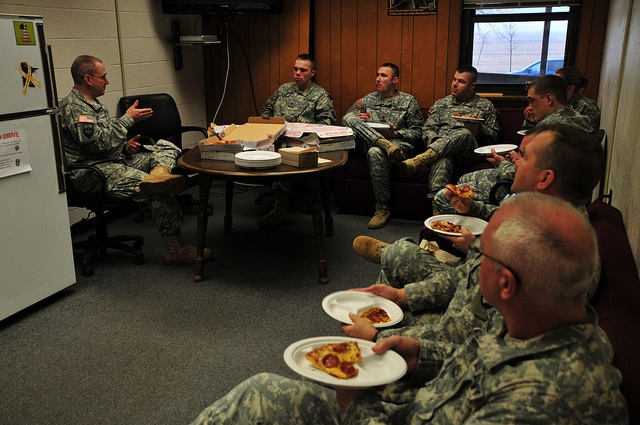Describe the objects in this image and their specific colors. I can see people in gray, black, and maroon tones, refrigerator in gray and black tones, people in gray, black, darkgreen, and tan tones, people in gray, black, darkgreen, and maroon tones, and dining table in gray, black, maroon, and tan tones in this image. 